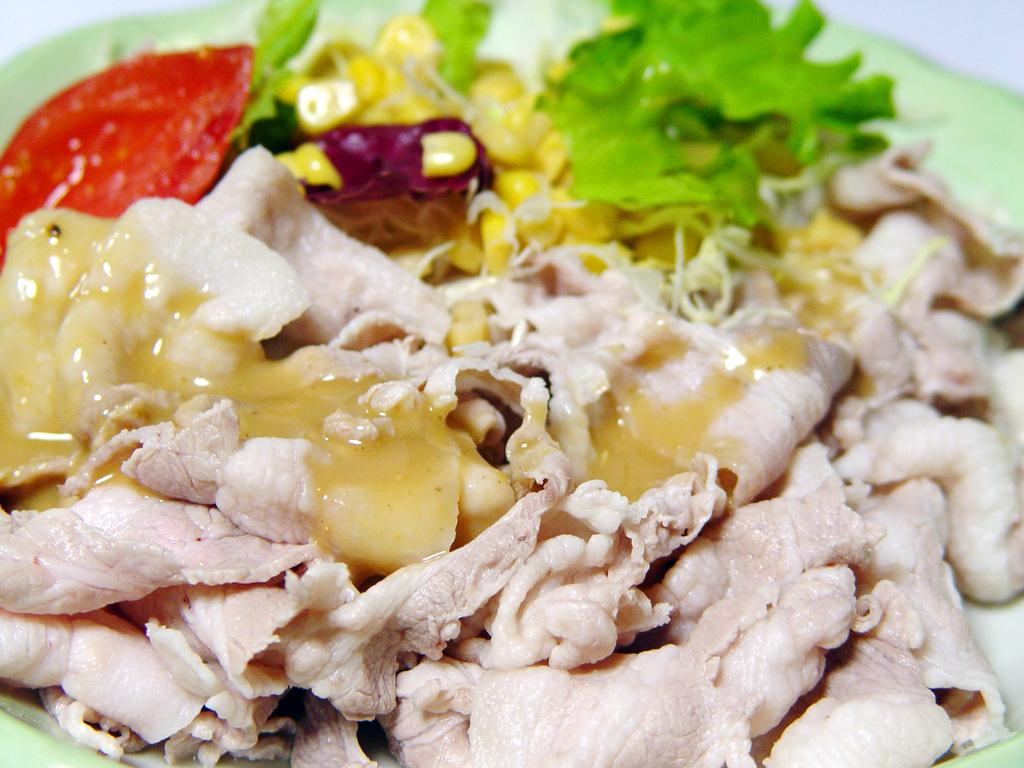What type of food can be seen in the image? There is meat and cooked vegetables in the image. What accompanies the meat and vegetables in the image? There is a sauce in the image. Can you describe the setting where the food is located? The image may have been taken in a room. What type of apparel is being worn by the yard in the image? There is no yard or apparel present in the image; it features food items and a sauce. 